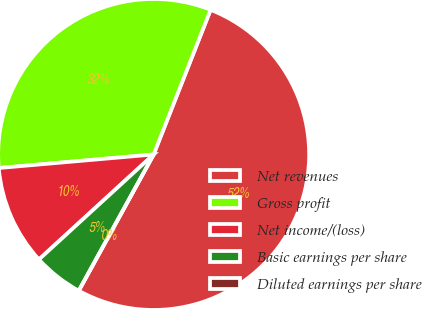<chart> <loc_0><loc_0><loc_500><loc_500><pie_chart><fcel>Net revenues<fcel>Gross profit<fcel>Net income/(loss)<fcel>Basic earnings per share<fcel>Diluted earnings per share<nl><fcel>52.03%<fcel>32.36%<fcel>10.41%<fcel>5.2%<fcel>0.0%<nl></chart> 